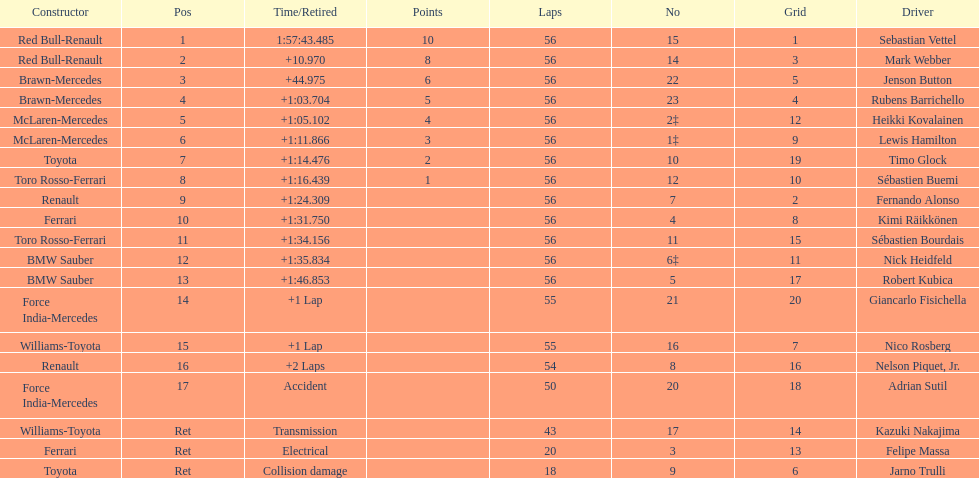How many laps in total is the race? 56. 